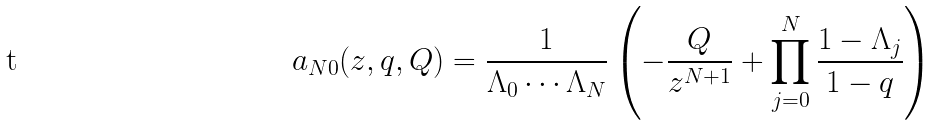Convert formula to latex. <formula><loc_0><loc_0><loc_500><loc_500>a _ { N 0 } ( z , q , Q ) = \frac { 1 } { \Lambda _ { 0 } \cdots \Lambda _ { N } } \left ( - \frac { Q } { z ^ { N + 1 } } + \prod _ { j = 0 } ^ { N } \frac { 1 - \Lambda _ { j } } { 1 - q } \right )</formula> 